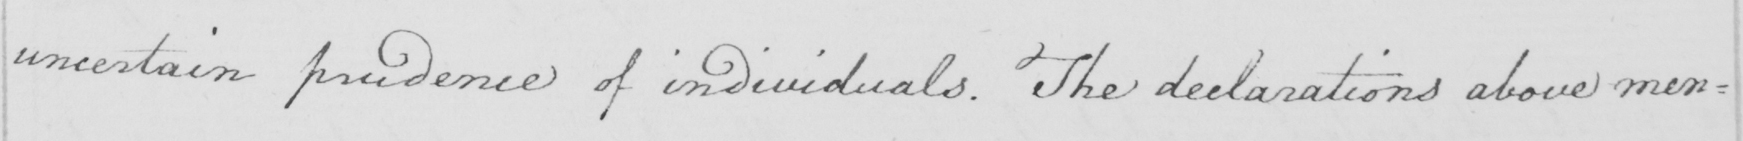Please transcribe the handwritten text in this image. uncertain prudence of individuals. The declarations above men= 